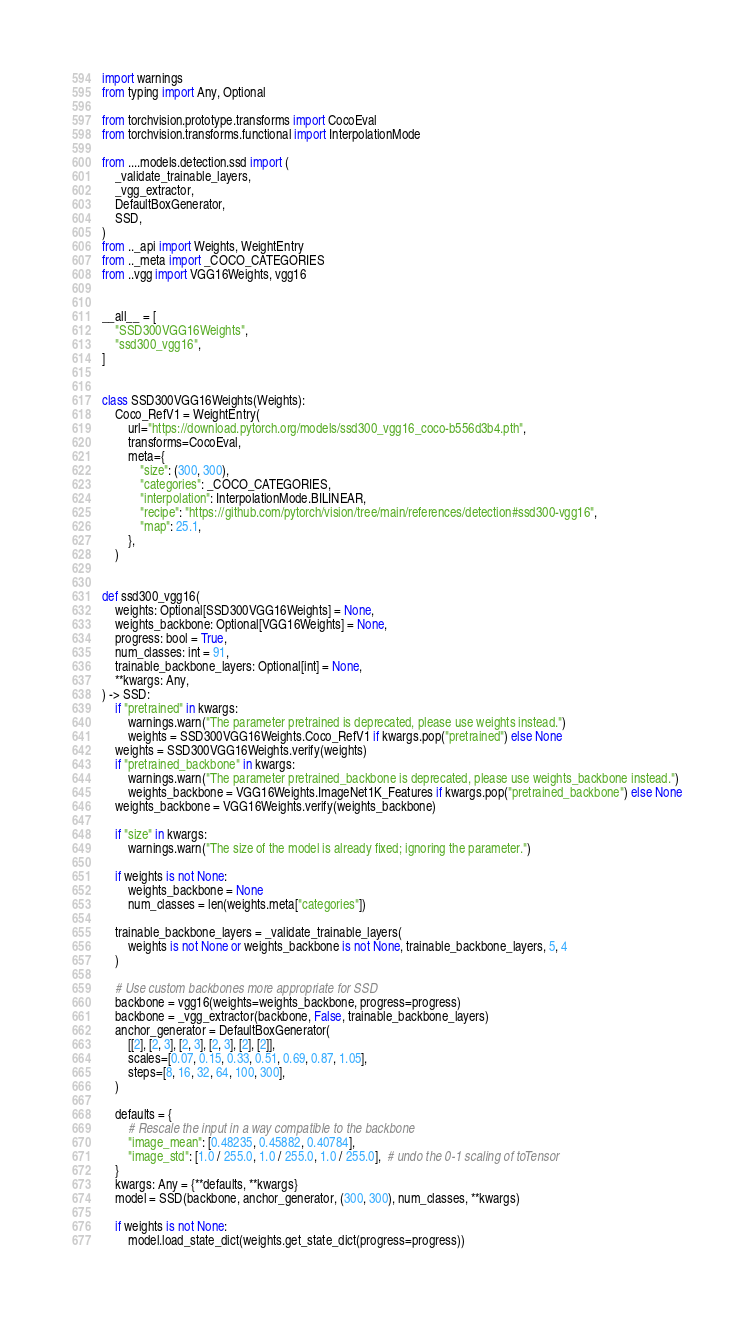<code> <loc_0><loc_0><loc_500><loc_500><_Python_>import warnings
from typing import Any, Optional

from torchvision.prototype.transforms import CocoEval
from torchvision.transforms.functional import InterpolationMode

from ....models.detection.ssd import (
    _validate_trainable_layers,
    _vgg_extractor,
    DefaultBoxGenerator,
    SSD,
)
from .._api import Weights, WeightEntry
from .._meta import _COCO_CATEGORIES
from ..vgg import VGG16Weights, vgg16


__all__ = [
    "SSD300VGG16Weights",
    "ssd300_vgg16",
]


class SSD300VGG16Weights(Weights):
    Coco_RefV1 = WeightEntry(
        url="https://download.pytorch.org/models/ssd300_vgg16_coco-b556d3b4.pth",
        transforms=CocoEval,
        meta={
            "size": (300, 300),
            "categories": _COCO_CATEGORIES,
            "interpolation": InterpolationMode.BILINEAR,
            "recipe": "https://github.com/pytorch/vision/tree/main/references/detection#ssd300-vgg16",
            "map": 25.1,
        },
    )


def ssd300_vgg16(
    weights: Optional[SSD300VGG16Weights] = None,
    weights_backbone: Optional[VGG16Weights] = None,
    progress: bool = True,
    num_classes: int = 91,
    trainable_backbone_layers: Optional[int] = None,
    **kwargs: Any,
) -> SSD:
    if "pretrained" in kwargs:
        warnings.warn("The parameter pretrained is deprecated, please use weights instead.")
        weights = SSD300VGG16Weights.Coco_RefV1 if kwargs.pop("pretrained") else None
    weights = SSD300VGG16Weights.verify(weights)
    if "pretrained_backbone" in kwargs:
        warnings.warn("The parameter pretrained_backbone is deprecated, please use weights_backbone instead.")
        weights_backbone = VGG16Weights.ImageNet1K_Features if kwargs.pop("pretrained_backbone") else None
    weights_backbone = VGG16Weights.verify(weights_backbone)

    if "size" in kwargs:
        warnings.warn("The size of the model is already fixed; ignoring the parameter.")

    if weights is not None:
        weights_backbone = None
        num_classes = len(weights.meta["categories"])

    trainable_backbone_layers = _validate_trainable_layers(
        weights is not None or weights_backbone is not None, trainable_backbone_layers, 5, 4
    )

    # Use custom backbones more appropriate for SSD
    backbone = vgg16(weights=weights_backbone, progress=progress)
    backbone = _vgg_extractor(backbone, False, trainable_backbone_layers)
    anchor_generator = DefaultBoxGenerator(
        [[2], [2, 3], [2, 3], [2, 3], [2], [2]],
        scales=[0.07, 0.15, 0.33, 0.51, 0.69, 0.87, 1.05],
        steps=[8, 16, 32, 64, 100, 300],
    )

    defaults = {
        # Rescale the input in a way compatible to the backbone
        "image_mean": [0.48235, 0.45882, 0.40784],
        "image_std": [1.0 / 255.0, 1.0 / 255.0, 1.0 / 255.0],  # undo the 0-1 scaling of toTensor
    }
    kwargs: Any = {**defaults, **kwargs}
    model = SSD(backbone, anchor_generator, (300, 300), num_classes, **kwargs)

    if weights is not None:
        model.load_state_dict(weights.get_state_dict(progress=progress))
</code> 